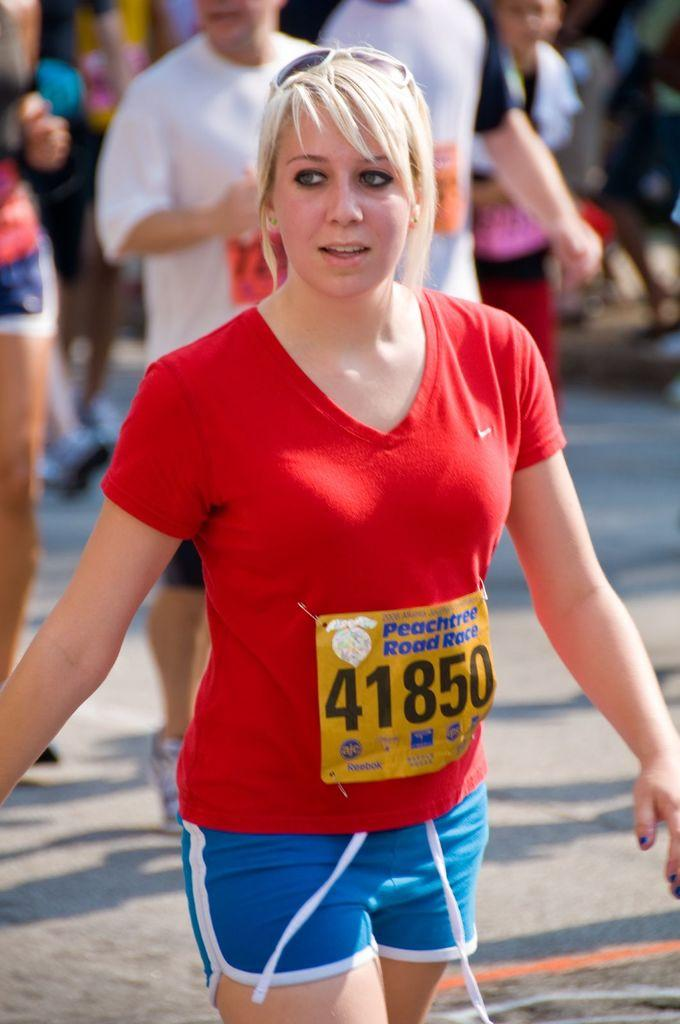<image>
Offer a succinct explanation of the picture presented. A woman is wearing a red shirt with Peachtree Road Race 41850 bib on it. 